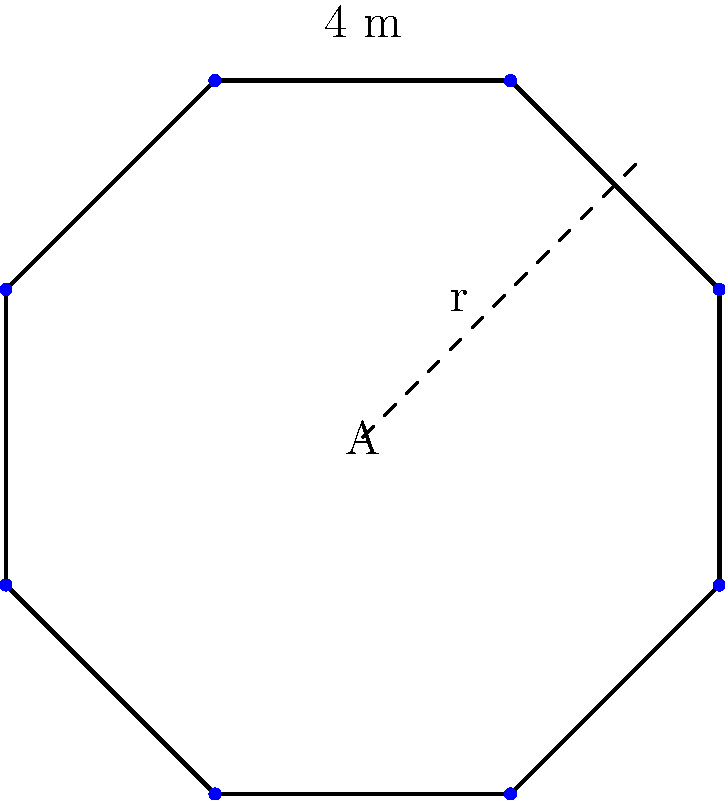The new baptismal font in your church has an octagonal shape. Each side of the octagon measures 4 meters. What is the total area of the baptismal font? (Use $\pi \approx 3.14$ and round your answer to the nearest square meter.) To find the area of the octagonal baptismal font, we'll follow these steps:

1) First, we need to find the radius (r) of the circumscribed circle of the octagon. For a regular octagon with side length s, the radius is given by:

   $r = \frac{s}{2\tan(\frac{\pi}{8})}$

2) Substituting s = 4 meters:

   $r = \frac{4}{2\tan(\frac{\pi}{8})} \approx 5.36$ meters

3) Now, we can calculate the area of the octagon using the formula:

   $A = 2r^2(1+\sqrt{2})$

4) Substituting our calculated r:

   $A = 2(5.36)^2(1+\sqrt{2})$

5) Simplifying:

   $A = 2(28.73)(2.414) \approx 138.63$ square meters

6) Rounding to the nearest square meter:

   $A \approx 139$ square meters

This area represents the total surface of the baptismal font, which is crucial for determining the amount of water it can hold and the space it occupies in the church.
Answer: 139 square meters 